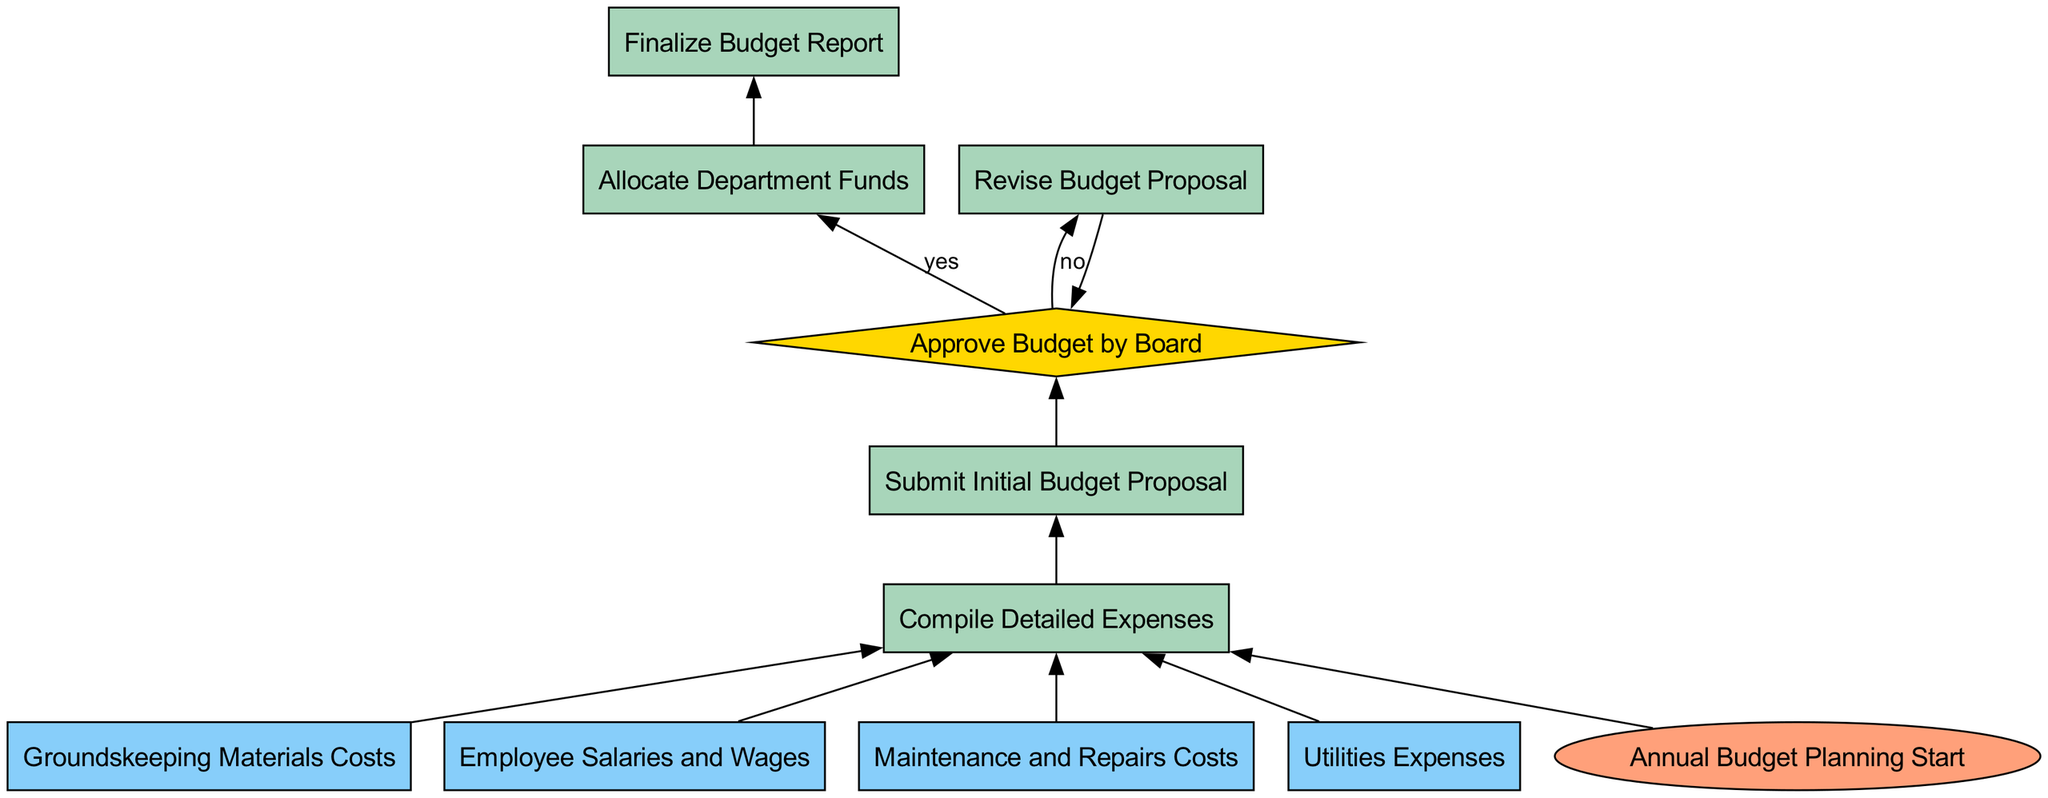What is the starting point of the budget allocation process? The diagram indicates that the starting point of the budget allocation process is "Annual Budget Planning Start," which is the first node in the flowchart.
Answer: Annual Budget Planning Start How many variable nodes are present in the diagram? By examining the diagram, we can identify the variable nodes: Groundskeeping Materials Costs, Employee Salaries and Wages, Maintenance and Repairs Costs, and Utilities Expenses. There are a total of four such nodes.
Answer: 4 What action occurs immediately after compiling detailed expenses? Following the "Compile Detailed Expenses" node, the next action is to "Submit Initial Budget Proposal." This shows the flow from the expense compilation to the proposal submission.
Answer: Submit Initial Budget Proposal What happens if the budget is not approved by the board? If the budget is not approved by the board, the flowchart indicates that it leads to "Revise Budget Proposal." This step is clearly outlined as an alternative path based on the decision node.
Answer: Revise Budget Proposal What is the final step in the budget allocation flow? According to the flowchart, the final process in the budget allocation flow is "Finalize Budget Report," which is reached after successfully allocating department funds.
Answer: Finalize Budget Report Which node leads directly to the approval decision by the board? The node that leads directly to the "Approve Budget by Board" decision is "Submit Initial Budget Proposal," indicating its importance in the budget approval process.
Answer: Submit Initial Budget Proposal What is required before allocating department funds? The flowchart specifies that "Approve Budget by Board" must occur before moving to "Allocate Department Funds," highlighting a critical step in the process.
Answer: Approve Budget by Board Which node is a decision point in the flowchart? The diagram shows that "Approve Budget by Board" is the only decision point in the flowchart, represented as a diamond shape.
Answer: Approve Budget by Board 